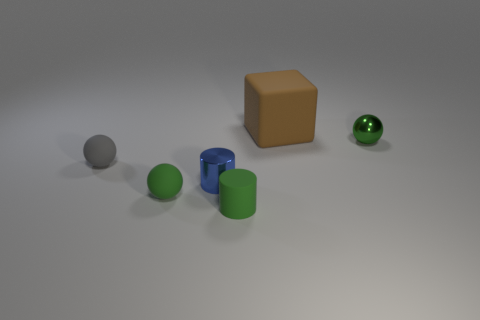Is the number of tiny yellow metallic cubes greater than the number of green matte things?
Offer a very short reply. No. There is a small thing that is to the right of the large block; is it the same color as the matte ball that is in front of the small blue thing?
Your response must be concise. Yes. Is the material of the green sphere that is to the right of the tiny green rubber sphere the same as the small green ball in front of the tiny gray rubber thing?
Your response must be concise. No. What number of gray spheres have the same size as the green matte ball?
Offer a very short reply. 1. Is the number of red metal cylinders less than the number of tiny green balls?
Keep it short and to the point. Yes. The object that is behind the tiny ball that is to the right of the tiny metallic cylinder is what shape?
Give a very brief answer. Cube. What shape is the gray rubber object that is the same size as the green rubber ball?
Ensure brevity in your answer.  Sphere. Are there any other small things of the same shape as the small blue shiny object?
Give a very brief answer. Yes. What is the gray object made of?
Give a very brief answer. Rubber. Are there any small green spheres to the right of the brown cube?
Your response must be concise. Yes. 